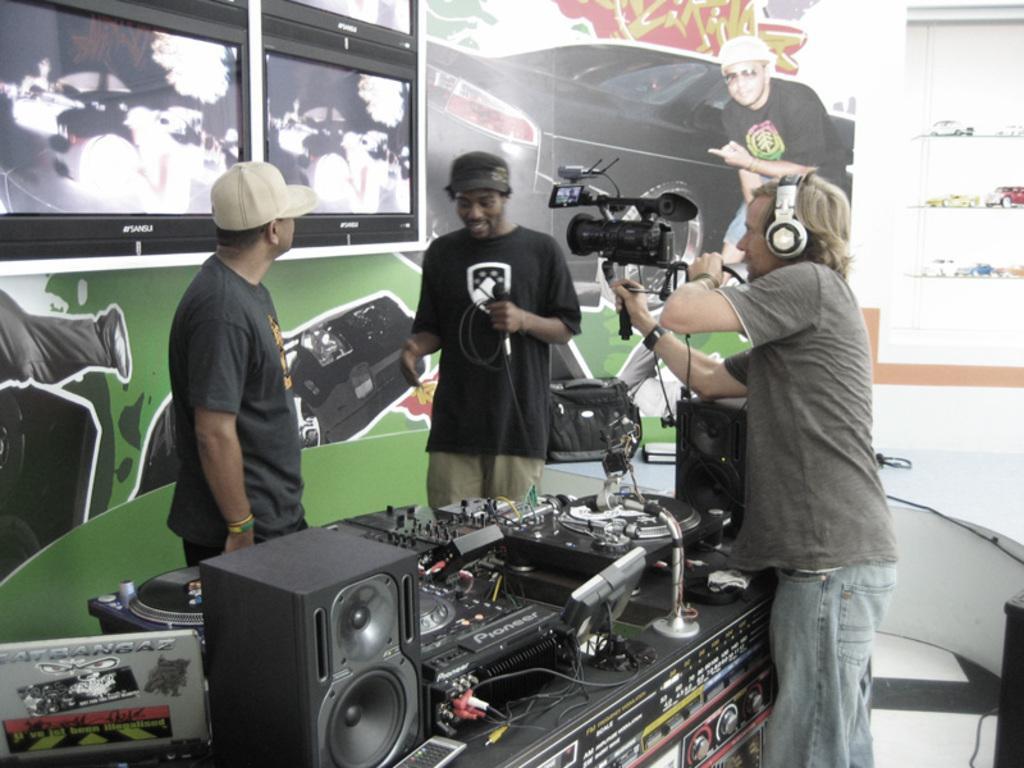Can you describe this image briefly? In the picture we can see three men are standing, one man is holding a microphone and talking something and beside him we can see a man standing and watching him and one man is capturing it with a camera and near them we can see a table with Digital Jockey and sound box and in the background we can see a wall with some paintings and two TV screens. 